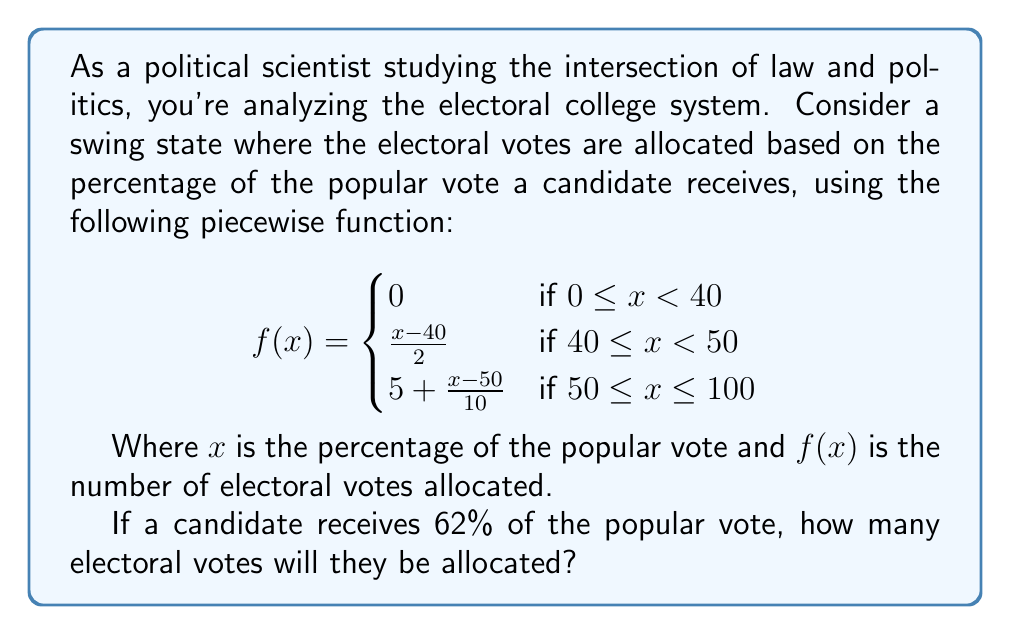Solve this math problem. To solve this problem, we need to follow these steps:

1) First, we identify which piece of the function applies to our input. Since $x = 62$, and $62 > 50$, we use the third piece of the function:

   $f(x) = 5 + \frac{x-50}{10}$ for $50 \leq x \leq 100$

2) Now, we substitute $x = 62$ into this equation:

   $f(62) = 5 + \frac{62-50}{10}$

3) Simplify the numerator:
   
   $f(62) = 5 + \frac{12}{10}$

4) Perform the division:
   
   $f(62) = 5 + 1.2$

5) Add the results:
   
   $f(62) = 6.2$

Therefore, the candidate will be allocated 6.2 electoral votes.
Answer: 6.2 electoral votes 